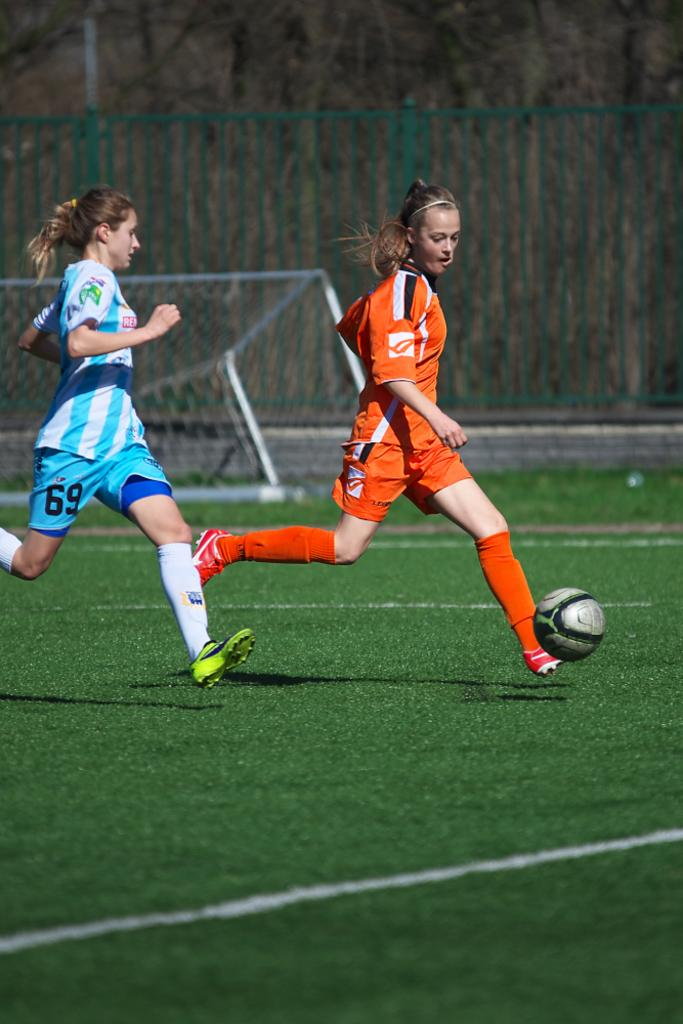<image>
Provide a brief description of the given image. a couple of soccer players one with the number 69 on their pants 